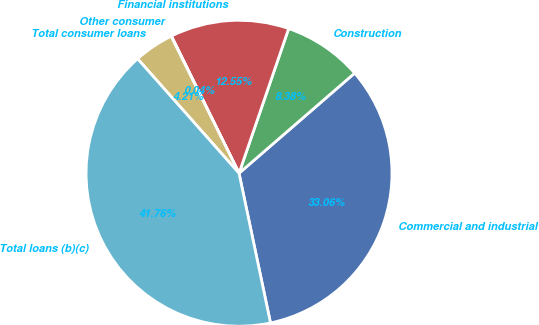Convert chart. <chart><loc_0><loc_0><loc_500><loc_500><pie_chart><fcel>Commercial and industrial<fcel>Construction<fcel>Financial institutions<fcel>Other consumer<fcel>Total consumer loans<fcel>Total loans (b)(c)<nl><fcel>33.06%<fcel>8.38%<fcel>12.55%<fcel>0.04%<fcel>4.21%<fcel>41.76%<nl></chart> 